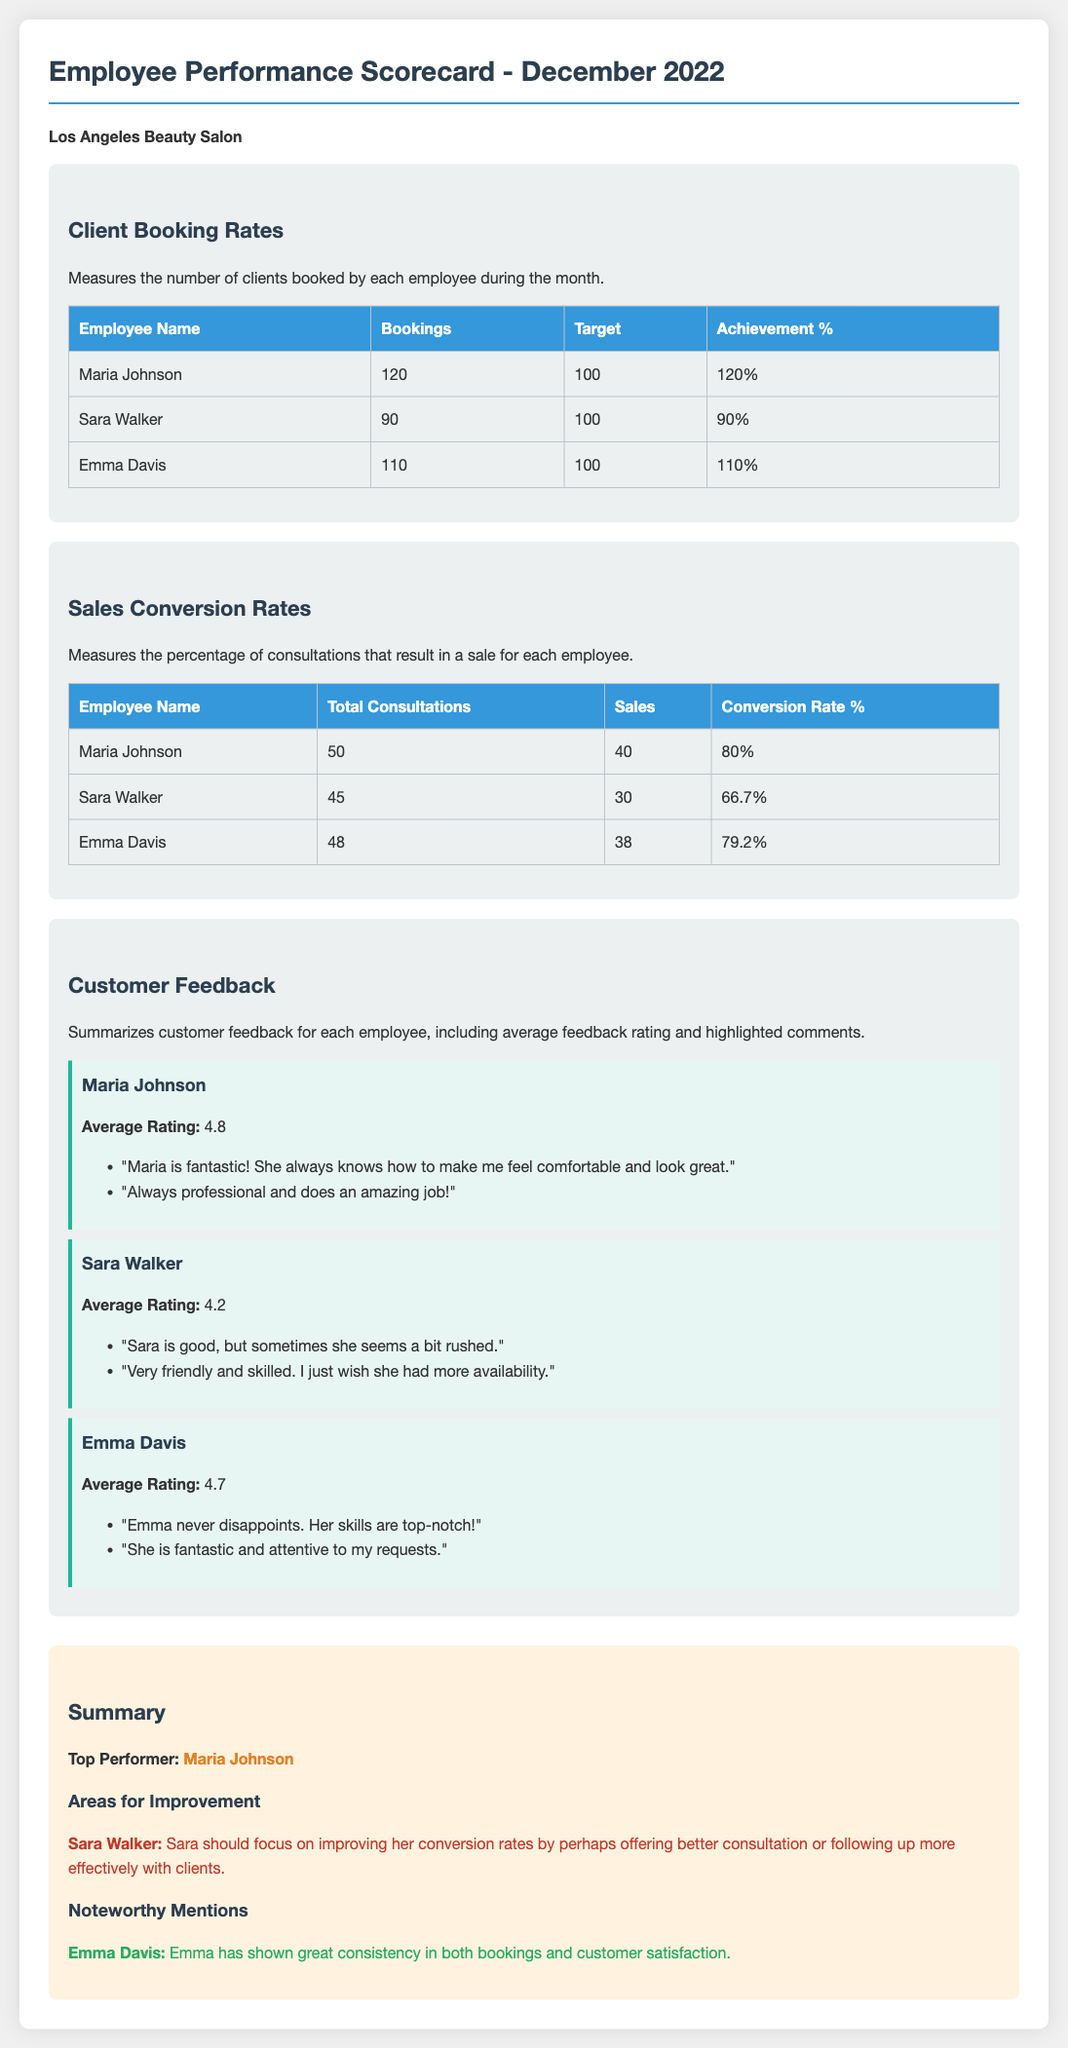What was Maria Johnson's total number of bookings? Maria Johnson booked a total of 120 clients in December 2022.
Answer: 120 What is Sara Walker's sales conversion rate? Sara Walker achieved a conversion rate of 66.7% during December 2022.
Answer: 66.7% Who had the highest average customer feedback rating? The employee with the highest average rating is Maria Johnson, with a score of 4.8.
Answer: Maria Johnson What are the target bookings for all employees? All employees had a target of 100 bookings for December 2022.
Answer: 100 What area should Sara Walker focus on for improvement? Sara Walker should focus on improving her conversion rates by enhancing her consultations.
Answer: Conversion rates Which employee is recognized for consistency in both bookings and customer satisfaction? Emma Davis is noted for her consistency in bookings and customer satisfaction.
Answer: Emma Davis How many total consultations did Emma Davis have? Emma Davis had a total of 48 consultations during the month.
Answer: 48 What was the noteworthy comment about Emma Davis? A noteworthy comment about Emma Davis is that "Her skills are top-notch!"
Answer: Top-notch What is the total number of sales generated by Maria Johnson? Maria Johnson generated a total of 40 sales from her consultations.
Answer: 40 